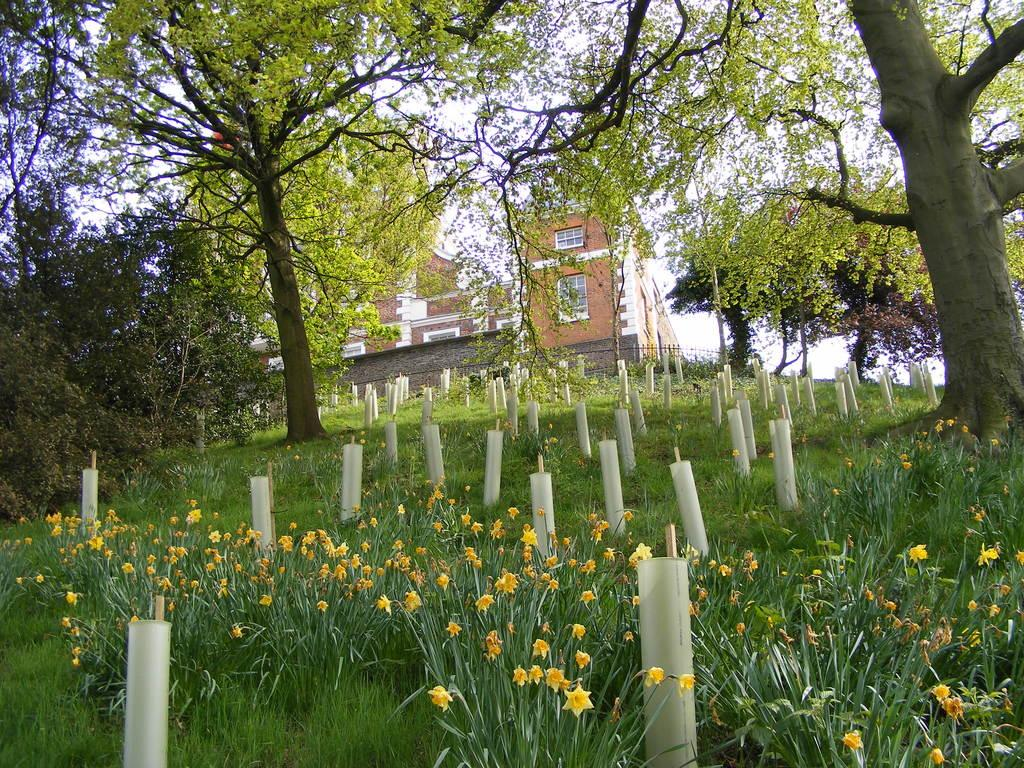What type of vegetation can be seen in the image? There are trees, plants, and flowers in the image. What type of structure is present in the image? There is a house in the image. How many mice can be seen playing a whistle in the image? There are no mice or whistles present in the image. 